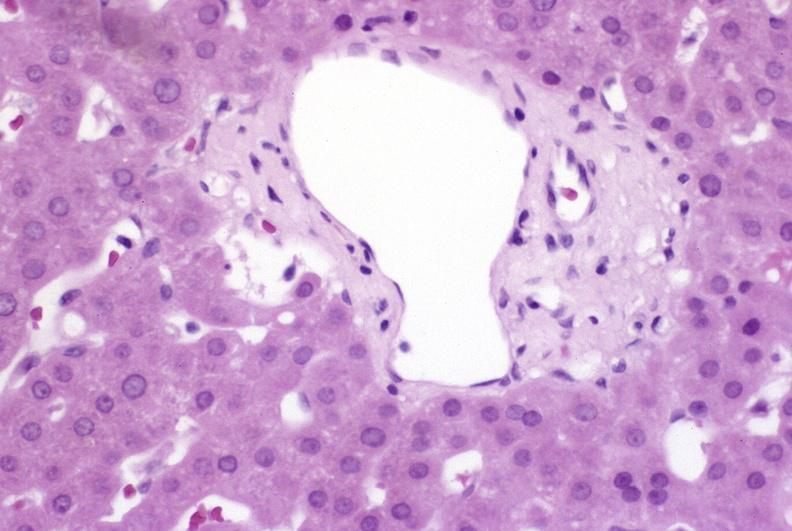does mesothelioma show ductopenia?
Answer the question using a single word or phrase. No 